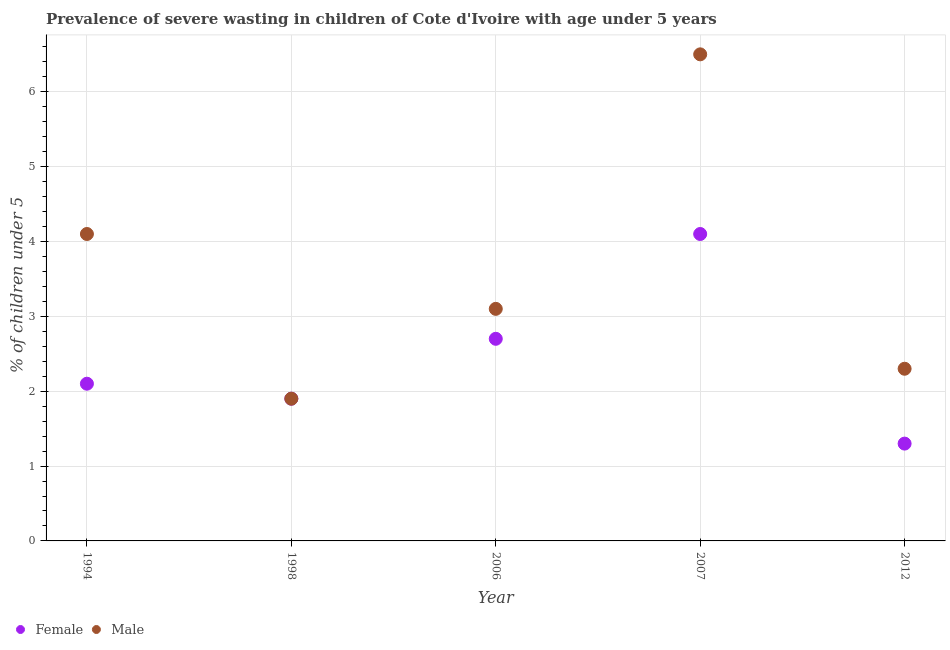Is the number of dotlines equal to the number of legend labels?
Provide a succinct answer. Yes. What is the percentage of undernourished female children in 2007?
Provide a succinct answer. 4.1. Across all years, what is the maximum percentage of undernourished male children?
Keep it short and to the point. 6.5. Across all years, what is the minimum percentage of undernourished female children?
Make the answer very short. 1.3. What is the total percentage of undernourished female children in the graph?
Give a very brief answer. 12.1. What is the difference between the percentage of undernourished male children in 1998 and that in 2007?
Offer a terse response. -4.6. What is the difference between the percentage of undernourished male children in 1994 and the percentage of undernourished female children in 2012?
Offer a terse response. 2.8. What is the average percentage of undernourished female children per year?
Make the answer very short. 2.42. In the year 2006, what is the difference between the percentage of undernourished male children and percentage of undernourished female children?
Make the answer very short. 0.4. In how many years, is the percentage of undernourished male children greater than 1.6 %?
Provide a short and direct response. 5. What is the ratio of the percentage of undernourished female children in 1998 to that in 2006?
Ensure brevity in your answer.  0.7. Is the difference between the percentage of undernourished male children in 2006 and 2012 greater than the difference between the percentage of undernourished female children in 2006 and 2012?
Your answer should be very brief. No. What is the difference between the highest and the second highest percentage of undernourished male children?
Your response must be concise. 2.4. What is the difference between the highest and the lowest percentage of undernourished male children?
Make the answer very short. 4.6. Is the sum of the percentage of undernourished male children in 1994 and 2006 greater than the maximum percentage of undernourished female children across all years?
Offer a terse response. Yes. Does the percentage of undernourished female children monotonically increase over the years?
Make the answer very short. No. How many dotlines are there?
Keep it short and to the point. 2. How many years are there in the graph?
Keep it short and to the point. 5. What is the difference between two consecutive major ticks on the Y-axis?
Your answer should be very brief. 1. Does the graph contain any zero values?
Your answer should be very brief. No. What is the title of the graph?
Offer a terse response. Prevalence of severe wasting in children of Cote d'Ivoire with age under 5 years. Does "Urban" appear as one of the legend labels in the graph?
Keep it short and to the point. No. What is the label or title of the X-axis?
Your answer should be compact. Year. What is the label or title of the Y-axis?
Make the answer very short.  % of children under 5. What is the  % of children under 5 of Female in 1994?
Keep it short and to the point. 2.1. What is the  % of children under 5 in Male in 1994?
Your answer should be very brief. 4.1. What is the  % of children under 5 of Female in 1998?
Provide a short and direct response. 1.9. What is the  % of children under 5 of Male in 1998?
Your response must be concise. 1.9. What is the  % of children under 5 of Female in 2006?
Your response must be concise. 2.7. What is the  % of children under 5 of Male in 2006?
Make the answer very short. 3.1. What is the  % of children under 5 in Female in 2007?
Make the answer very short. 4.1. What is the  % of children under 5 of Female in 2012?
Keep it short and to the point. 1.3. What is the  % of children under 5 of Male in 2012?
Make the answer very short. 2.3. Across all years, what is the maximum  % of children under 5 of Female?
Provide a succinct answer. 4.1. Across all years, what is the minimum  % of children under 5 in Female?
Provide a short and direct response. 1.3. Across all years, what is the minimum  % of children under 5 of Male?
Your answer should be very brief. 1.9. What is the total  % of children under 5 of Female in the graph?
Provide a short and direct response. 12.1. What is the difference between the  % of children under 5 in Female in 1994 and that in 1998?
Provide a succinct answer. 0.2. What is the difference between the  % of children under 5 in Male in 1994 and that in 2006?
Your response must be concise. 1. What is the difference between the  % of children under 5 in Female in 1994 and that in 2007?
Ensure brevity in your answer.  -2. What is the difference between the  % of children under 5 in Female in 1994 and that in 2012?
Offer a very short reply. 0.8. What is the difference between the  % of children under 5 in Female in 1998 and that in 2006?
Ensure brevity in your answer.  -0.8. What is the difference between the  % of children under 5 in Female in 1998 and that in 2007?
Offer a terse response. -2.2. What is the difference between the  % of children under 5 of Male in 1998 and that in 2007?
Offer a very short reply. -4.6. What is the difference between the  % of children under 5 of Female in 2006 and that in 2007?
Your response must be concise. -1.4. What is the difference between the  % of children under 5 in Male in 2006 and that in 2012?
Offer a terse response. 0.8. What is the difference between the  % of children under 5 of Female in 1994 and the  % of children under 5 of Male in 1998?
Give a very brief answer. 0.2. What is the difference between the  % of children under 5 in Female in 1994 and the  % of children under 5 in Male in 2007?
Give a very brief answer. -4.4. What is the difference between the  % of children under 5 in Female in 2007 and the  % of children under 5 in Male in 2012?
Make the answer very short. 1.8. What is the average  % of children under 5 in Female per year?
Make the answer very short. 2.42. What is the average  % of children under 5 in Male per year?
Ensure brevity in your answer.  3.58. In the year 1994, what is the difference between the  % of children under 5 of Female and  % of children under 5 of Male?
Offer a very short reply. -2. In the year 2007, what is the difference between the  % of children under 5 of Female and  % of children under 5 of Male?
Make the answer very short. -2.4. In the year 2012, what is the difference between the  % of children under 5 in Female and  % of children under 5 in Male?
Offer a very short reply. -1. What is the ratio of the  % of children under 5 in Female in 1994 to that in 1998?
Offer a very short reply. 1.11. What is the ratio of the  % of children under 5 of Male in 1994 to that in 1998?
Offer a terse response. 2.16. What is the ratio of the  % of children under 5 in Female in 1994 to that in 2006?
Keep it short and to the point. 0.78. What is the ratio of the  % of children under 5 in Male in 1994 to that in 2006?
Your answer should be compact. 1.32. What is the ratio of the  % of children under 5 in Female in 1994 to that in 2007?
Provide a succinct answer. 0.51. What is the ratio of the  % of children under 5 of Male in 1994 to that in 2007?
Your response must be concise. 0.63. What is the ratio of the  % of children under 5 of Female in 1994 to that in 2012?
Your answer should be very brief. 1.62. What is the ratio of the  % of children under 5 of Male in 1994 to that in 2012?
Give a very brief answer. 1.78. What is the ratio of the  % of children under 5 of Female in 1998 to that in 2006?
Your answer should be very brief. 0.7. What is the ratio of the  % of children under 5 in Male in 1998 to that in 2006?
Provide a short and direct response. 0.61. What is the ratio of the  % of children under 5 of Female in 1998 to that in 2007?
Your answer should be compact. 0.46. What is the ratio of the  % of children under 5 in Male in 1998 to that in 2007?
Provide a short and direct response. 0.29. What is the ratio of the  % of children under 5 of Female in 1998 to that in 2012?
Give a very brief answer. 1.46. What is the ratio of the  % of children under 5 in Male in 1998 to that in 2012?
Your response must be concise. 0.83. What is the ratio of the  % of children under 5 of Female in 2006 to that in 2007?
Your answer should be compact. 0.66. What is the ratio of the  % of children under 5 of Male in 2006 to that in 2007?
Offer a terse response. 0.48. What is the ratio of the  % of children under 5 of Female in 2006 to that in 2012?
Your answer should be compact. 2.08. What is the ratio of the  % of children under 5 in Male in 2006 to that in 2012?
Keep it short and to the point. 1.35. What is the ratio of the  % of children under 5 of Female in 2007 to that in 2012?
Your response must be concise. 3.15. What is the ratio of the  % of children under 5 in Male in 2007 to that in 2012?
Your answer should be compact. 2.83. What is the difference between the highest and the second highest  % of children under 5 in Female?
Make the answer very short. 1.4. What is the difference between the highest and the second highest  % of children under 5 in Male?
Provide a short and direct response. 2.4. What is the difference between the highest and the lowest  % of children under 5 in Male?
Ensure brevity in your answer.  4.6. 